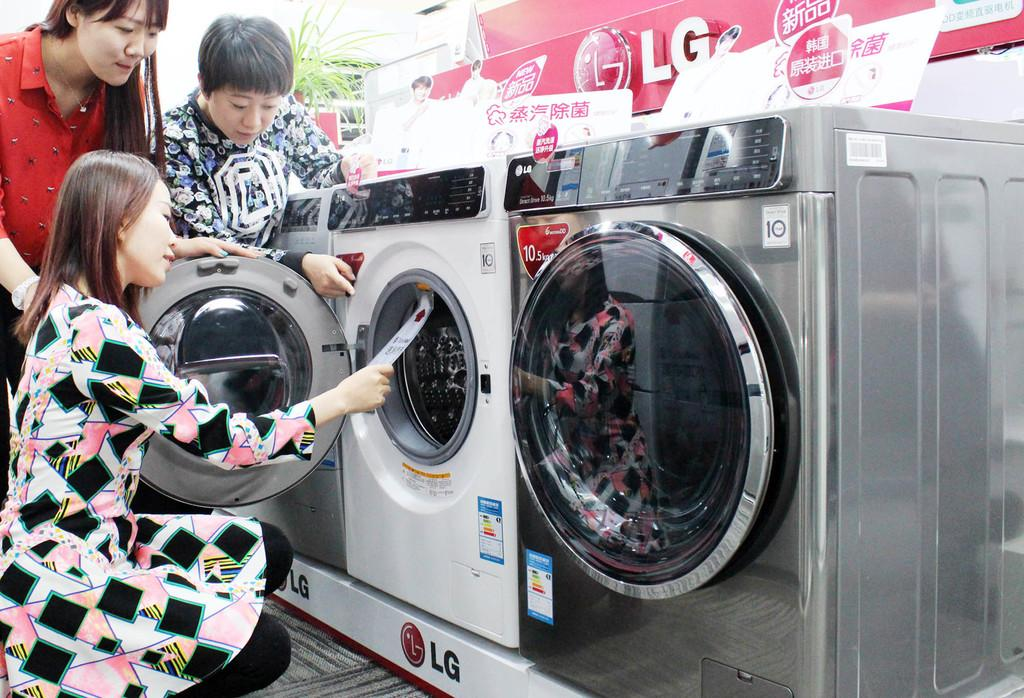What appliances can be seen on the floor in the image? There are washing machines on the floor in the image. How many people are present in the image? There are two persons standing in the image, and one person is in a squat position. What is the position of the person at the bottom of the image? The person at the bottom of the image is in a squat position. What can be seen at the top of the image? There is a plant and boards visible at the top of the image. What type of war is being depicted in the image? There is no depiction of war in the image; it features washing machines, people, a plant, and boards. How many trucks are visible in the image? There are no trucks present in the image. 